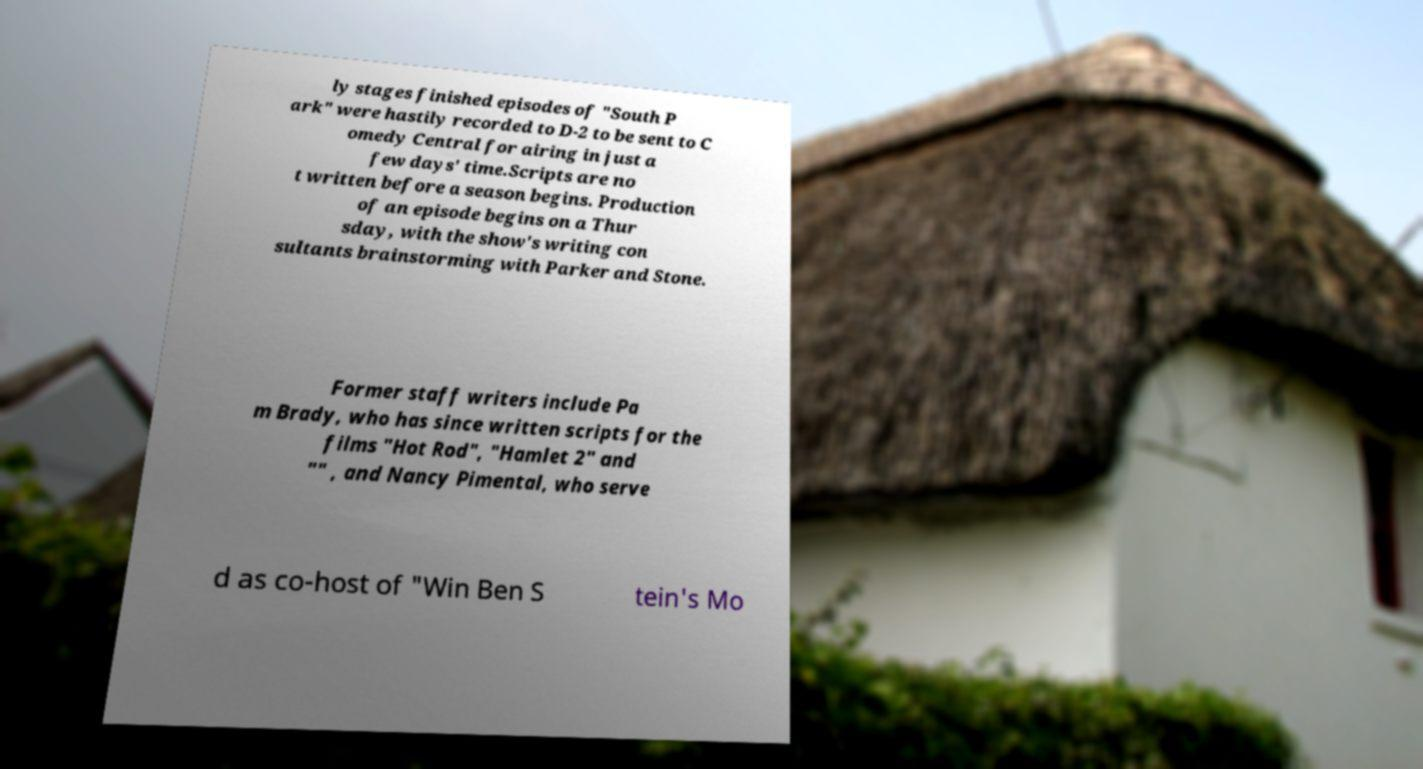Could you extract and type out the text from this image? ly stages finished episodes of "South P ark" were hastily recorded to D-2 to be sent to C omedy Central for airing in just a few days' time.Scripts are no t written before a season begins. Production of an episode begins on a Thur sday, with the show's writing con sultants brainstorming with Parker and Stone. Former staff writers include Pa m Brady, who has since written scripts for the films "Hot Rod", "Hamlet 2" and "" , and Nancy Pimental, who serve d as co-host of "Win Ben S tein's Mo 